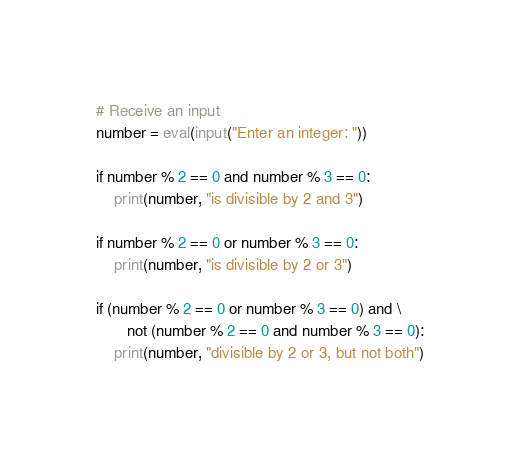<code> <loc_0><loc_0><loc_500><loc_500><_Python_># Receive an input
number = eval(input("Enter an integer: "))

if number % 2 == 0 and number % 3 == 0:
    print(number, "is divisible by 2 and 3")

if number % 2 == 0 or number % 3 == 0:
    print(number, "is divisible by 2 or 3")

if (number % 2 == 0 or number % 3 == 0) and \
       not (number % 2 == 0 and number % 3 == 0):
    print(number, "divisible by 2 or 3, but not both")
</code> 